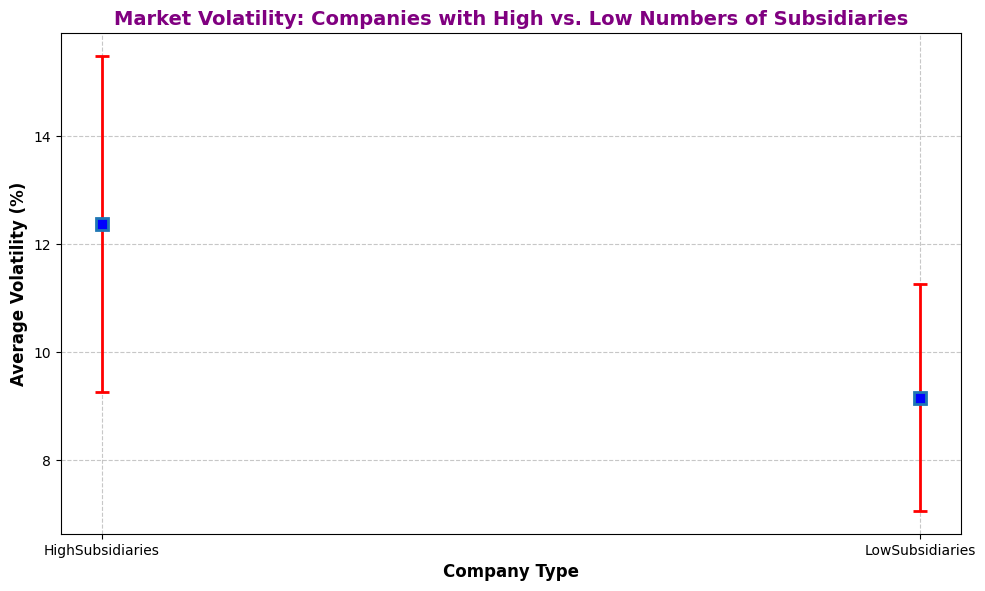What is the average market volatility for companies with high numbers of subsidiaries? The chart shows the average market volatility for companies with high numbers of subsidiaries by the height of the blue markers on the y-axis. The value corresponding to 'HighSubsidiaries' on the y-axis is 12.17%.
Answer: 12.17% Which group has a higher average market volatility? The chart compares the average market volatility for two groups: companies with high numbers of subsidiaries and those with low numbers. The blue marker for 'HighSubsidiaries' is higher than for 'LowSubsidiaries'.
Answer: Companies with high numbers of subsidiaries What is the difference in average market volatility between companies with high subsidiaries and low subsidiaries? From the chart, the 'HighSubsidiaries' group has an average volatility of 12.17%, and the 'LowSubsidiaries' group has an average volatility of 9.05%. The difference is calculated as 12.17% - 9.05%.
Answer: 3.12% Which group shows a higher standard deviation in market volatility? The chart indicates the standard deviation by the error bars. The error bars for 'HighSubsidiaries' are longer than for 'LowSubsidiaries', meaning the standard deviation is higher for the former.
Answer: HighSubsidiaries What is the range of market volatility for companies with low numbers of subsidiaries? The range can be calculated using the error bars for 'LowSubsidiaries'. The average volatility is 9.05%, and the standard deviation is 2.1%. The range is 9.05% ± 2.1%, which is from (9.05% - 2.1%) to (9.05% + 2.1%)
Answer: 6.95% to 11.15% How many total observations are there for the 'HighSubsidiaries' group? Each error bar corresponding to 'HighSubsidiaries' represents 50 observations. There are 10 markers, so the total number of observations is 10 x 50.
Answer: 500 If the average market volatility for companies with low subsidiaries is increased by 20%, what would the new average be? The current average for 'LowSubsidiaries' is 9.05%. Increasing this by 20% involves calculating 9.05% x 1.20.
Answer: 10.86% What is the visual difference between the two groups regarding marker color for average volatility? From the visual attributes, the markers for 'HighSubsidiaries' and 'LowSubsidiaries' are both blue. Hence, there's no color difference in markers between the two groups.
Answer: None Considering one standard deviation above and below the average, which group has a wider spread of values for market volatility? Examining the error bars, 'HighSubsidiaries' has its spread calculated as average ± 3.1%, compared to 'LowSubsidiaries' spread of average ± 2.1%. The spread for 'HighSubsidiaries' is wider.
Answer: HighSubsidiaries 